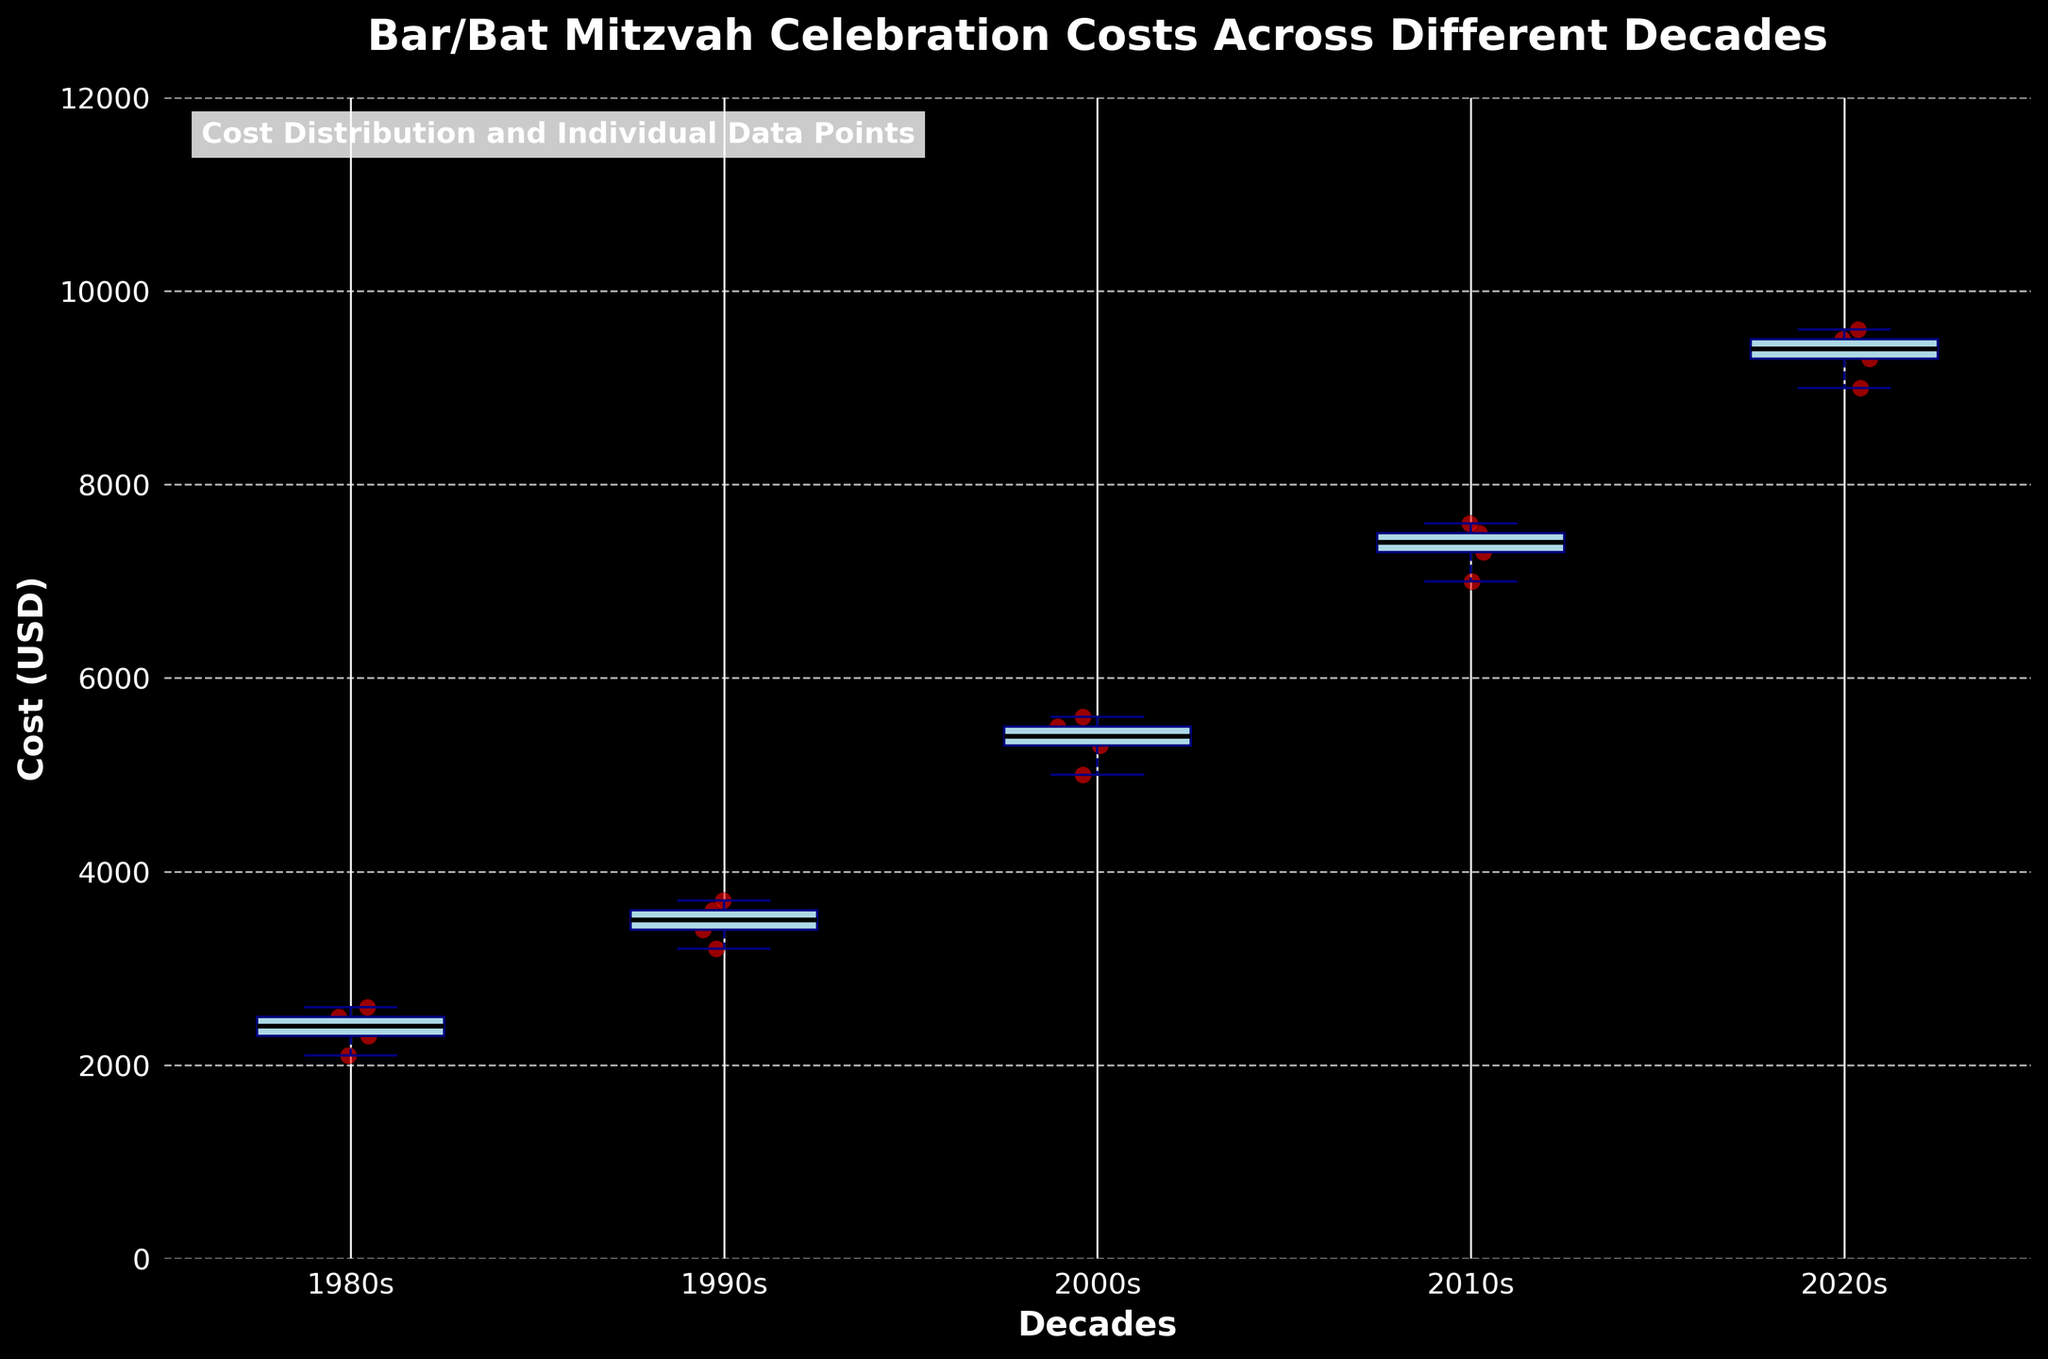what’s the title of the plot? The title is usually situated at the top of the plot. Here, it is written boldly in larger font over the graph.
Answer: Bar/Bat Mitzvah Celebration Costs Across Different Decades Which decade has the highest median celebration cost? Look for the black line inside the blue boxes, which represents the median value (most central line). The highest black line across all decades will be the highest median value.
Answer: 2020s How does the range of costs in the 1980s compare to that in the 2020s? Observe the lengths of the whiskers (dashed lines extending from the boxes) and the overall height of the boxes in the two decades to compare their ranges. The range is the difference between the highest and lowest points.
Answer: 2020s range is much larger What is the typical cost range for a celebration in the 2010s? The range is indicated by the top and bottom whiskers extending from the box. Look at these points on the y-axis to find the range.
Answer: 7000 to 7600 USD How many scatter points are in the 2000s decade? Count the red dots corresponding to the 2000s decade box plot. Each dot represents an individual data point.
Answer: 5 Which decade shows the least variation in celebration costs? Variation can be seen in the height of the boxes and the length of the whiskers. The decade with the smallest box and shortest whiskers indicates the least variation.
Answer: 1980s If the trend continues, what could be the expected range of celebration costs in the 2030s? By observing the trend over decades, it’s evident that costs generally increase. Estimation would involve projecting current increasing trends. Seeing how the range expands from earlier decades to the 2020s, one could add a similar increase for prediction.
Answer: Estimated 11000-14000 USD How does the cost variability in the 1990s compare to the variability in the 2010s? Variability is indicated by the difference between the top and bottom whiskers and the height of the boxes. Compare these two decades’ box and whisker lengths.
Answer: 2010s show less variability compared to 1990s Which locations and years have been considered in the 2020s? Look for the scatter points on the plot for the 2020s and locate those points at their specific years and locations of collection.
Answer: New York (2021), Chicago (2023), Los Angeles (2022), Miami (2022), San Francisco (2021) What's the median value and the interquartile range for the 2000s? The median is the central value (black line) within the box. The interquartile range is the height of the box (the difference between the 25th percentile and the 75th percentile). Read the values off the y-axis.
Answer: Median: 5400 USD, IQR: 5000-5600 USD 